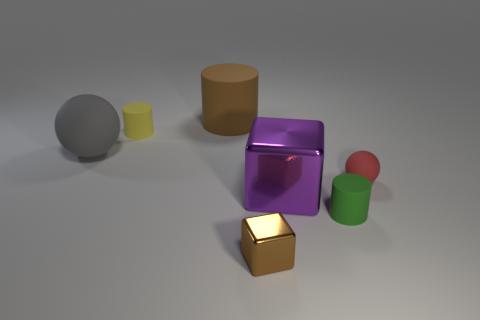Subtract all green balls. Subtract all cyan blocks. How many balls are left? 2 Add 2 tiny brown matte things. How many objects exist? 9 Subtract all cylinders. How many objects are left? 4 Add 5 large gray balls. How many large gray balls are left? 6 Add 7 brown cylinders. How many brown cylinders exist? 8 Subtract 0 red cylinders. How many objects are left? 7 Subtract all blue spheres. Subtract all yellow matte things. How many objects are left? 6 